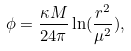<formula> <loc_0><loc_0><loc_500><loc_500>\phi = \frac { \kappa M } { 2 4 \pi } \ln ( \frac { r ^ { 2 } } { \mu ^ { 2 } } ) ,</formula> 